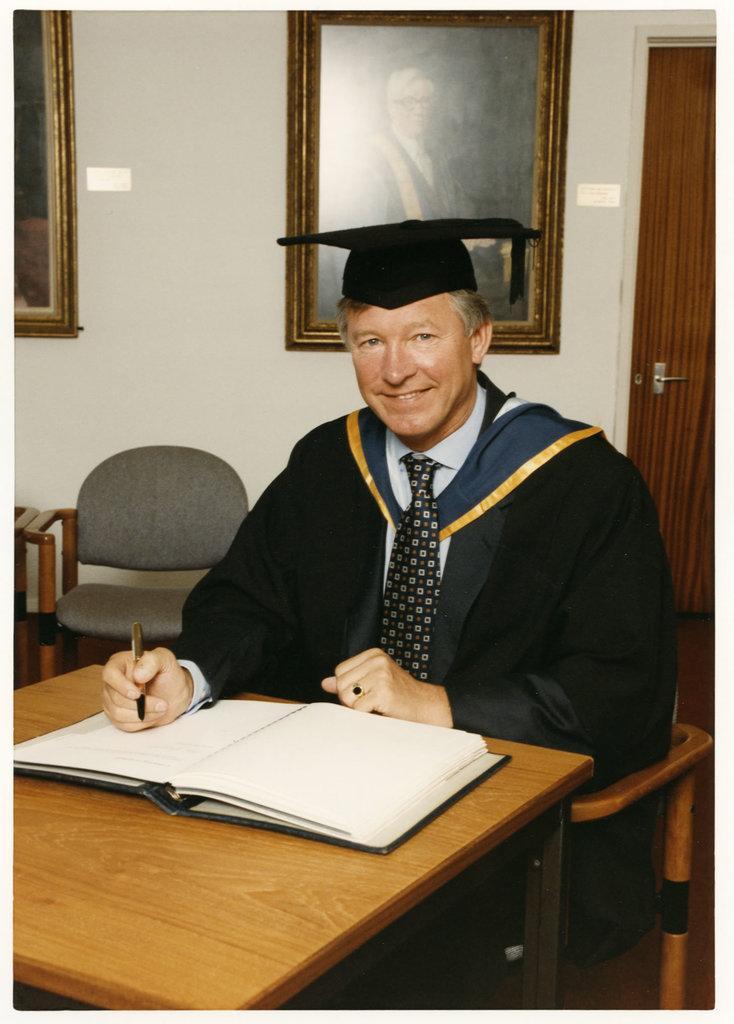Can you describe this image briefly? A man is sitting at a table with a pen in his hand and a book in front of him. 